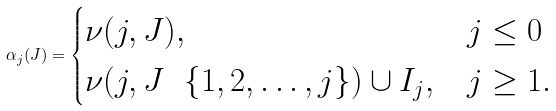Convert formula to latex. <formula><loc_0><loc_0><loc_500><loc_500>\alpha _ { j } ( J ) = \begin{cases} \nu ( j , J ) , & j \leq 0 \\ \nu ( j , J \, \ \, \{ 1 , 2 , \dots , j \} ) \cup I _ { j } , & j \geq 1 . \end{cases}</formula> 